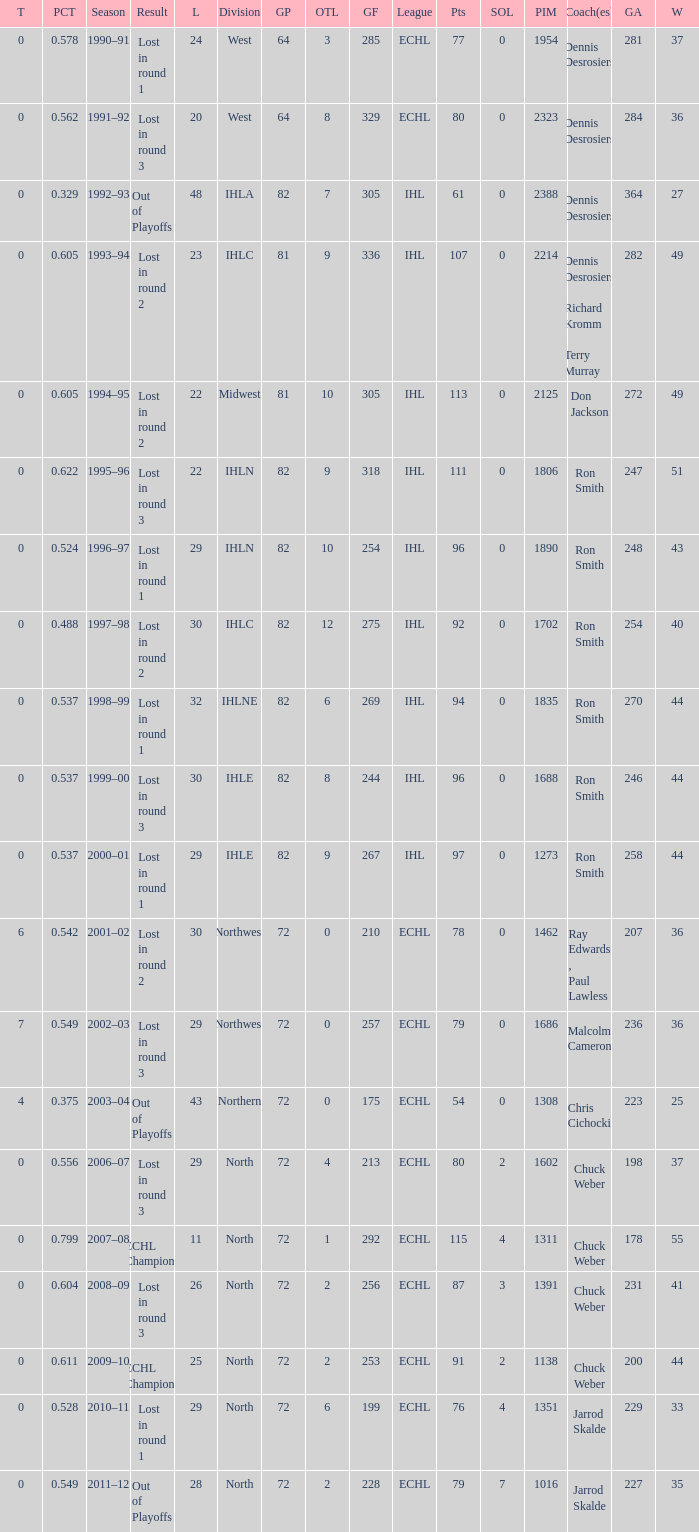What was the maximum OTL if L is 28? 2.0. 